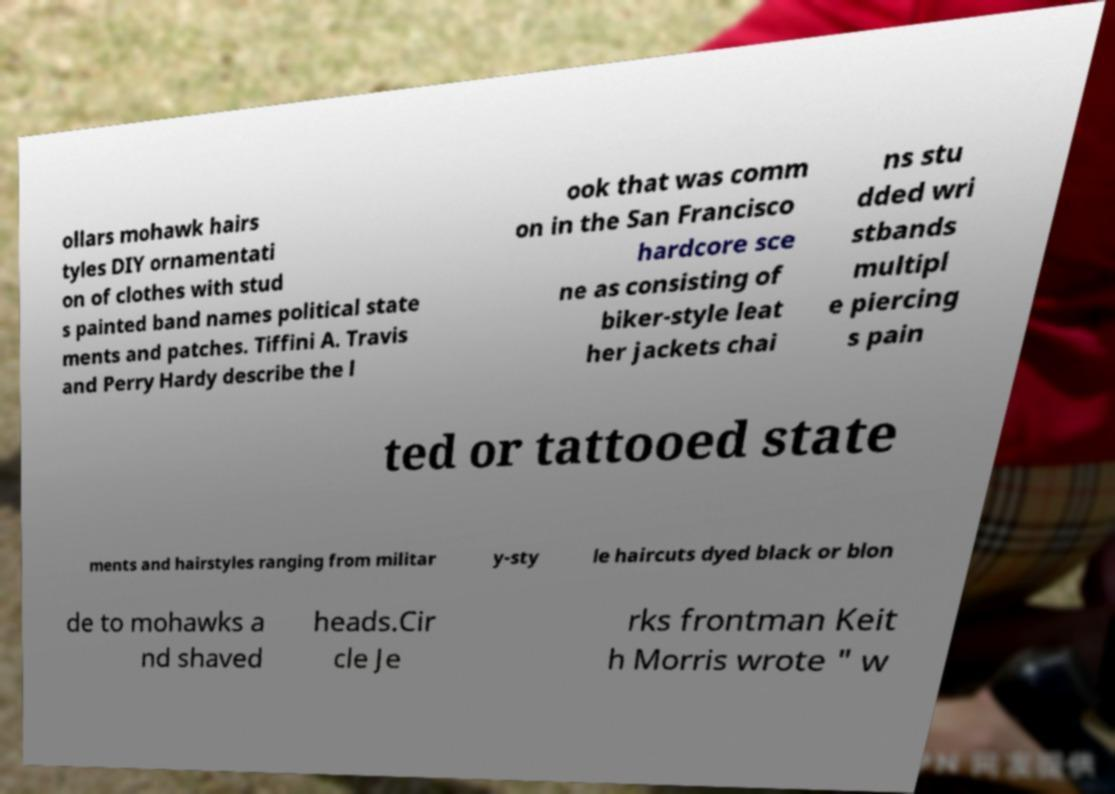Please read and relay the text visible in this image. What does it say? ollars mohawk hairs tyles DIY ornamentati on of clothes with stud s painted band names political state ments and patches. Tiffini A. Travis and Perry Hardy describe the l ook that was comm on in the San Francisco hardcore sce ne as consisting of biker-style leat her jackets chai ns stu dded wri stbands multipl e piercing s pain ted or tattooed state ments and hairstyles ranging from militar y-sty le haircuts dyed black or blon de to mohawks a nd shaved heads.Cir cle Je rks frontman Keit h Morris wrote " w 